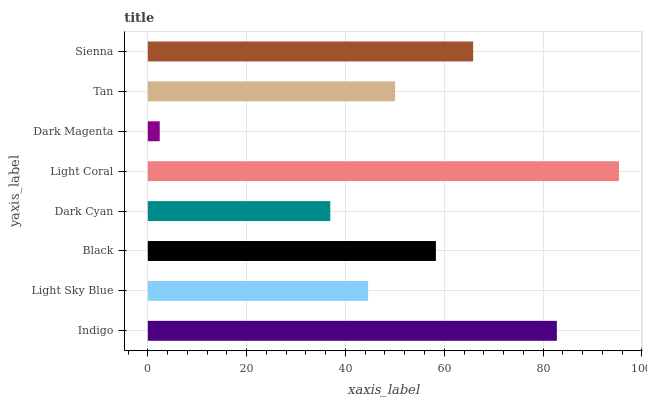Is Dark Magenta the minimum?
Answer yes or no. Yes. Is Light Coral the maximum?
Answer yes or no. Yes. Is Light Sky Blue the minimum?
Answer yes or no. No. Is Light Sky Blue the maximum?
Answer yes or no. No. Is Indigo greater than Light Sky Blue?
Answer yes or no. Yes. Is Light Sky Blue less than Indigo?
Answer yes or no. Yes. Is Light Sky Blue greater than Indigo?
Answer yes or no. No. Is Indigo less than Light Sky Blue?
Answer yes or no. No. Is Black the high median?
Answer yes or no. Yes. Is Tan the low median?
Answer yes or no. Yes. Is Light Sky Blue the high median?
Answer yes or no. No. Is Black the low median?
Answer yes or no. No. 